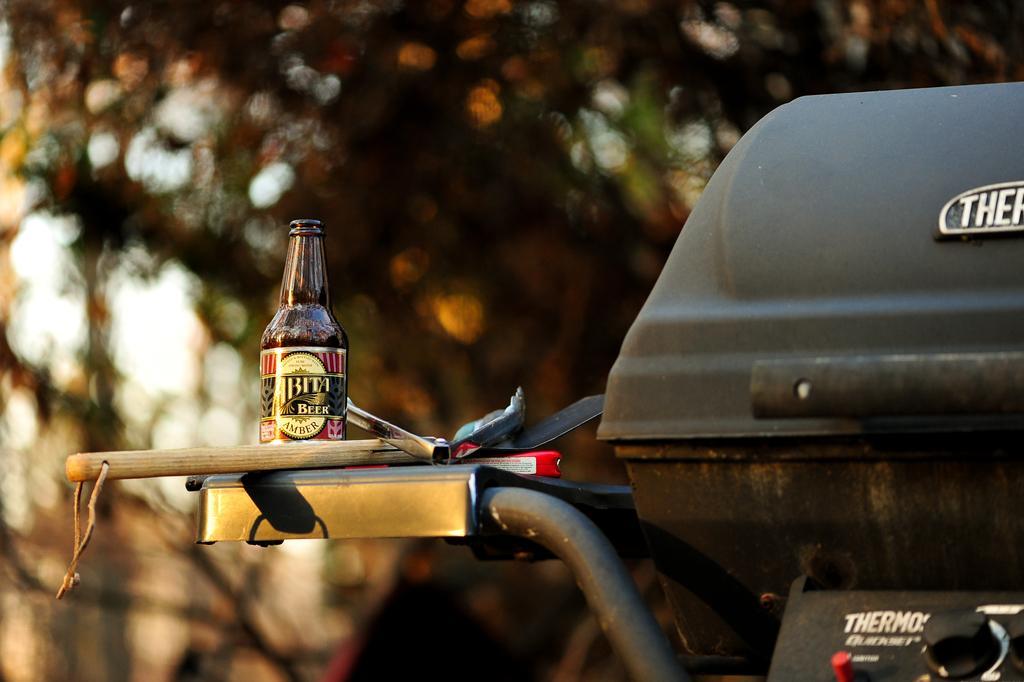In one or two sentences, can you explain what this image depicts? In this image in the center there is one vehicle and on the vehicle there is one bottle and some objects, in the background there are some trees. 